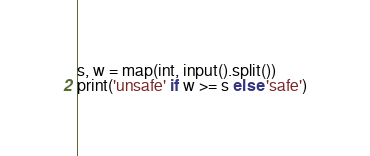<code> <loc_0><loc_0><loc_500><loc_500><_Python_>s, w = map(int, input().split())
print('unsafe' if w >= s else 'safe')</code> 